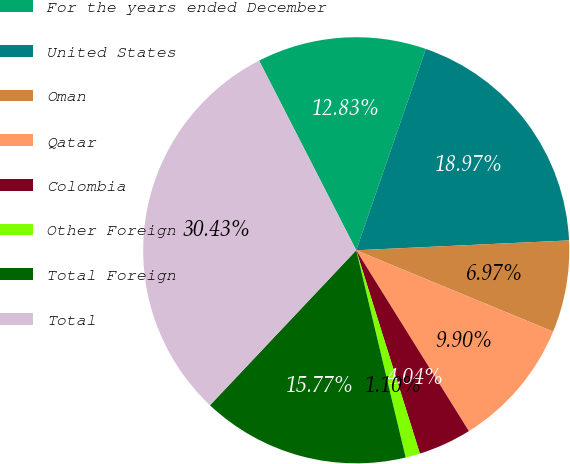Convert chart. <chart><loc_0><loc_0><loc_500><loc_500><pie_chart><fcel>For the years ended December<fcel>United States<fcel>Oman<fcel>Qatar<fcel>Colombia<fcel>Other Foreign<fcel>Total Foreign<fcel>Total<nl><fcel>12.83%<fcel>18.97%<fcel>6.97%<fcel>9.9%<fcel>4.04%<fcel>1.1%<fcel>15.77%<fcel>30.43%<nl></chart> 